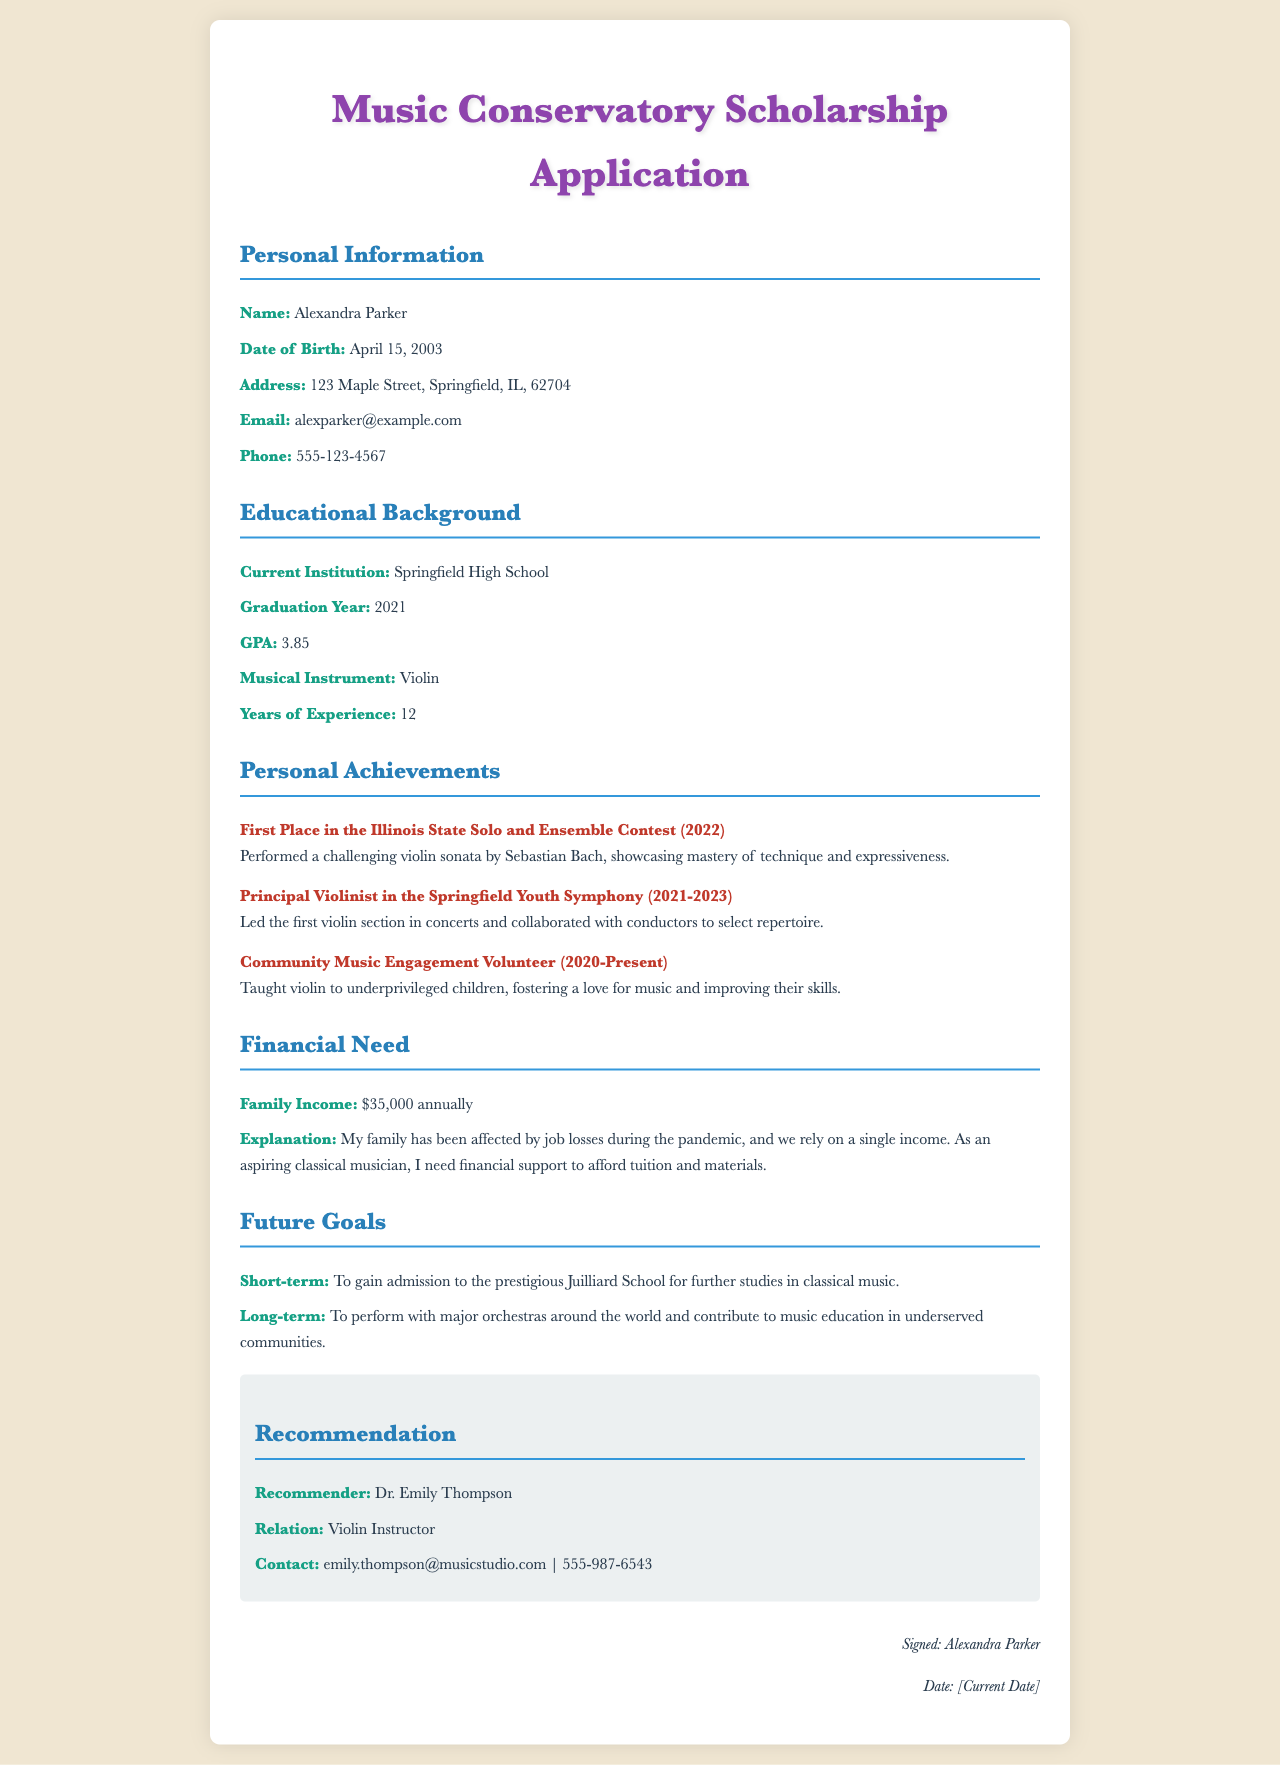What is the applicant's name? The applicant's name is explicitly stated in the personal information section of the document.
Answer: Alexandra Parker What is the musical instrument played by the applicant? The musical instrument is mentioned under the educational background section.
Answer: Violin How many years of experience does the applicant have? The number of years of experience is provided in the educational background information.
Answer: 12 What is the applicant's GPA? The GPA is listed in the educational background section as a measure of academic performance.
Answer: 3.85 Who wrote the recommendation for the applicant? The name of the recommender is provided in the recommendation section of the document.
Answer: Dr. Emily Thompson What place did the applicant achieve in the Illinois State Solo and Ensemble Contest? This achievement is highlighted in the personal achievements section of the document.
Answer: First Place What is the applicant's family income? The family income is clearly stated in the financial need section of the application.
Answer: $35,000 What is the applicant's short-term goal? The short-term goal is mentioned under the future goals section, reflecting the applicant's aspirations.
Answer: To gain admission to the prestigious Juilliard School What significant event affected the applicant's family income? This explanation is related to the financial need and provides context for the applicant's request.
Answer: Job losses during the pandemic What is the address provided by the applicant? The address is found in the personal information section of the document.
Answer: 123 Maple Street, Springfield, IL, 62704 